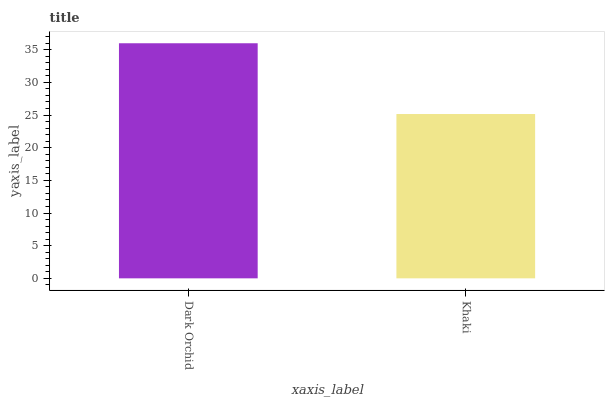Is Khaki the minimum?
Answer yes or no. Yes. Is Dark Orchid the maximum?
Answer yes or no. Yes. Is Khaki the maximum?
Answer yes or no. No. Is Dark Orchid greater than Khaki?
Answer yes or no. Yes. Is Khaki less than Dark Orchid?
Answer yes or no. Yes. Is Khaki greater than Dark Orchid?
Answer yes or no. No. Is Dark Orchid less than Khaki?
Answer yes or no. No. Is Dark Orchid the high median?
Answer yes or no. Yes. Is Khaki the low median?
Answer yes or no. Yes. Is Khaki the high median?
Answer yes or no. No. Is Dark Orchid the low median?
Answer yes or no. No. 